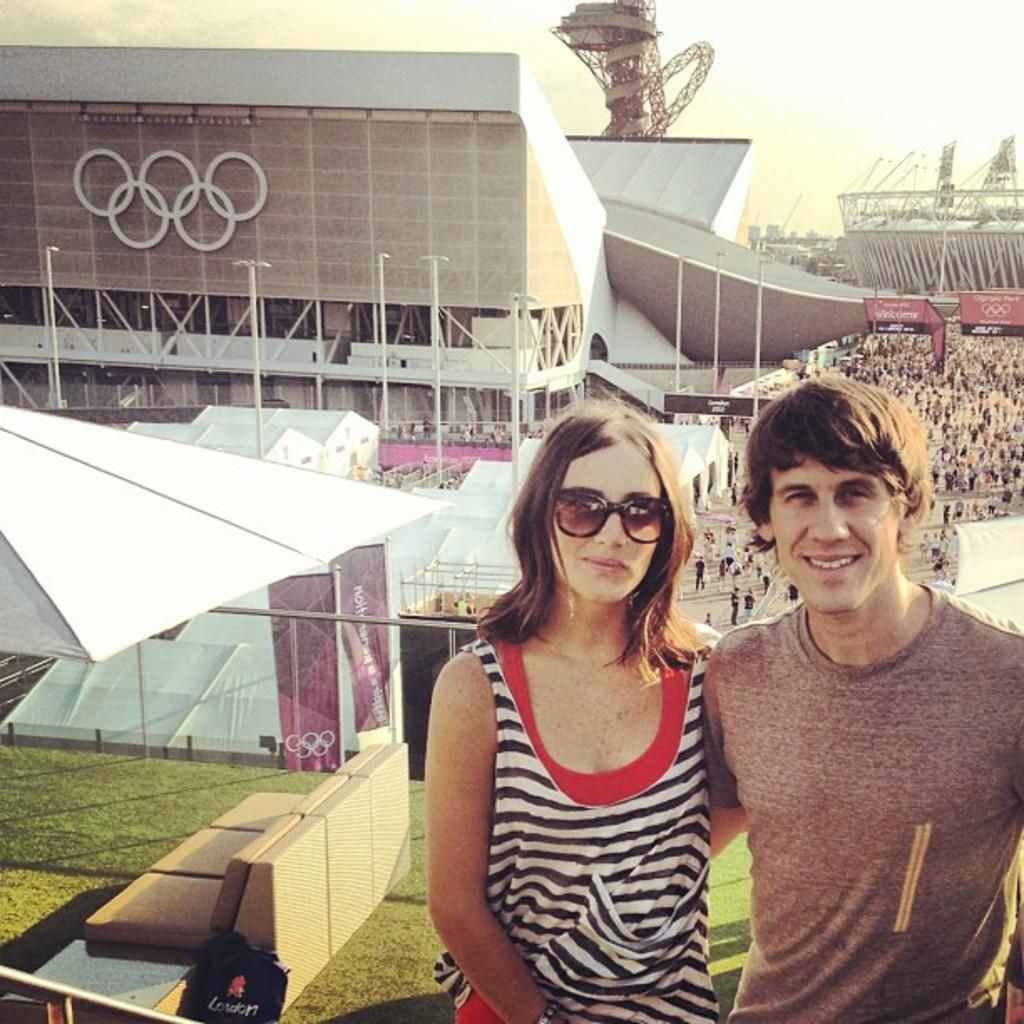How many people are in the image? There are two persons in the image. What is located behind the persons? There are stalls behind the persons. What type of terrain is visible in the image? Grass is present in the image. What type of signage is visible in the image? Banners are visible in the image. Can you describe the groups of people in the image? There are groups of people in the image. What can be seen in the background of the image? There are buildings in the background of the image. What is visible at the top of the image? The sky is visible in the image. What is the price of the meat being sold at the stalls in the image? There is no indication of any meat being sold at the stalls in the image, so it is not possible to determine the price. 